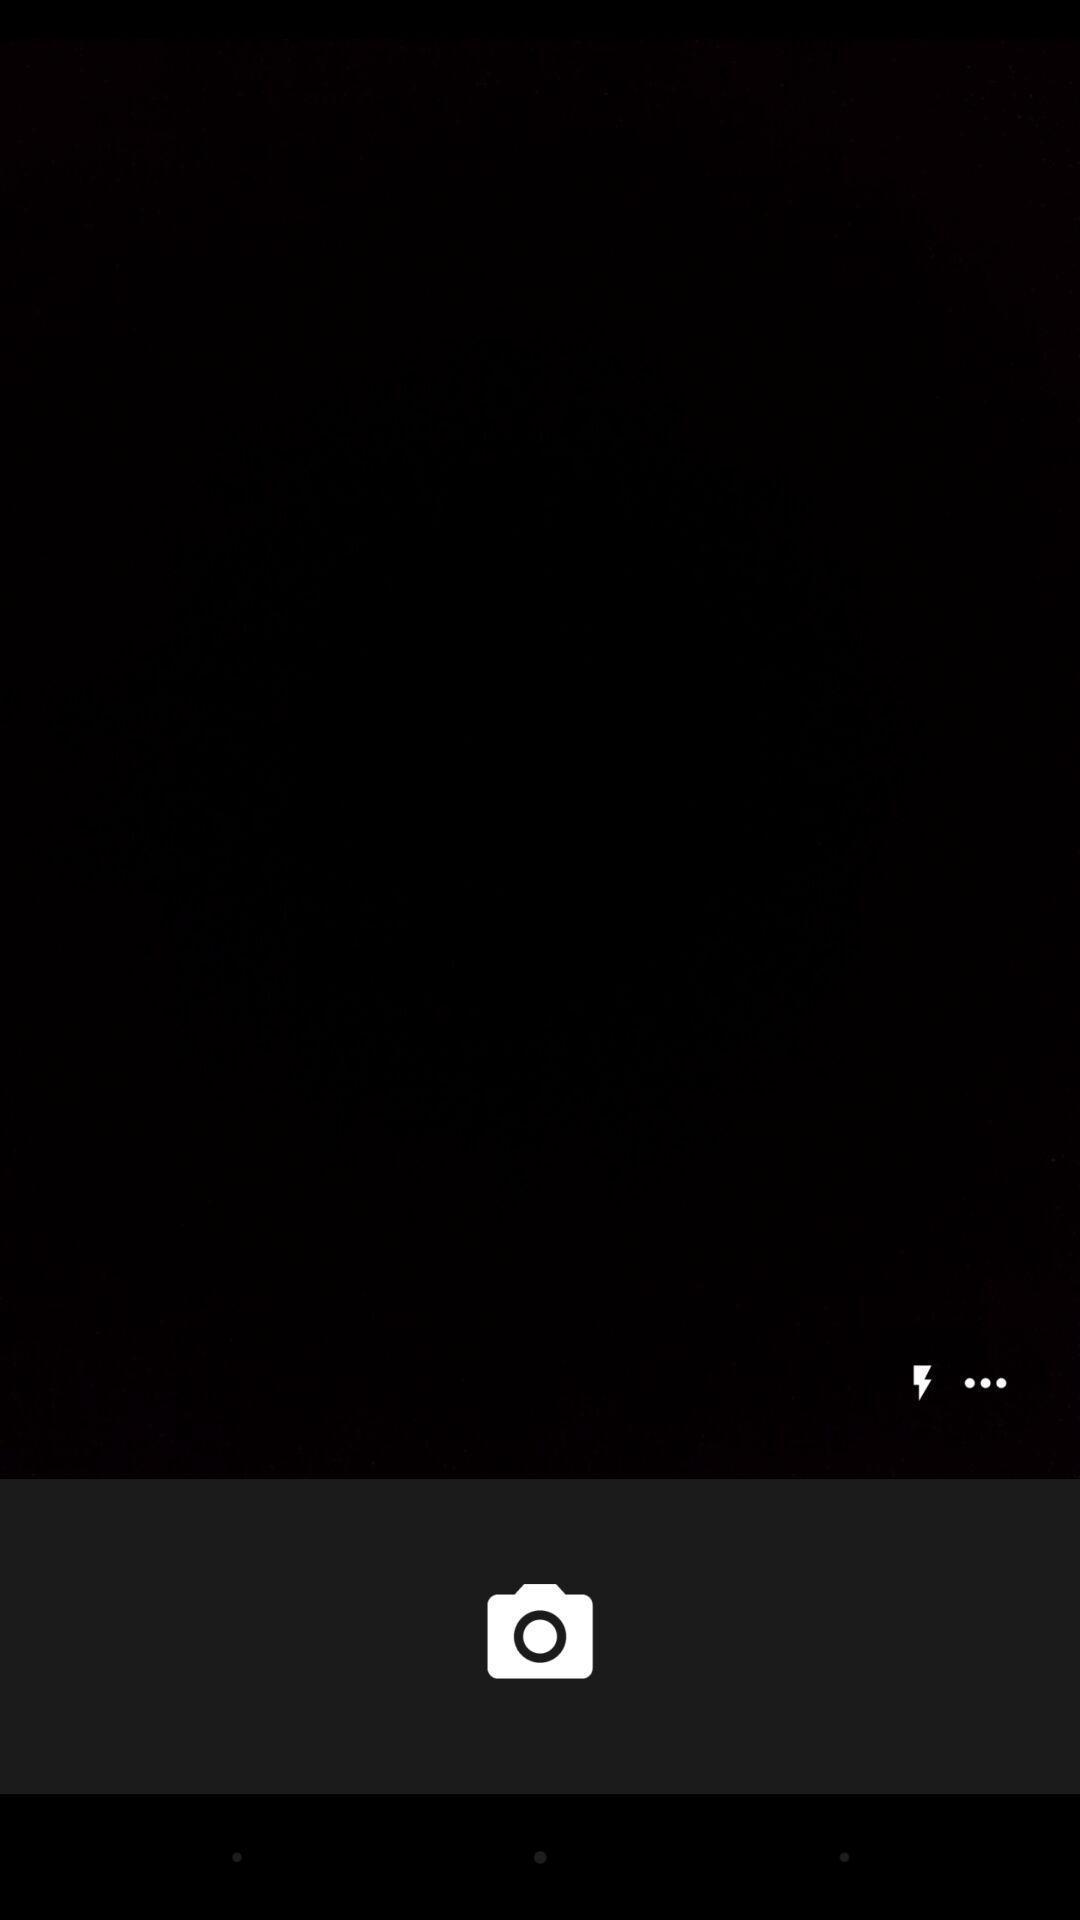Explain the elements present in this screenshot. Screen shows blank with a camera icon. 